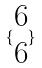<formula> <loc_0><loc_0><loc_500><loc_500>\{ \begin{matrix} 6 \\ 6 \end{matrix} \}</formula> 